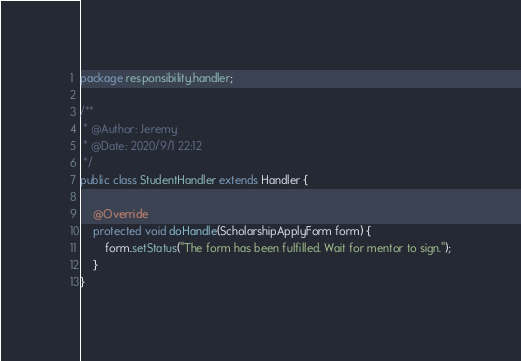<code> <loc_0><loc_0><loc_500><loc_500><_Java_>package responsibility.handler;

/**
 * @Author: Jeremy
 * @Date: 2020/9/1 22:12
 */
public class StudentHandler extends Handler {

    @Override
    protected void doHandle(ScholarshipApplyForm form) {
        form.setStatus("The form has been fulfilled. Wait for mentor to sign.");
    }
}
</code> 